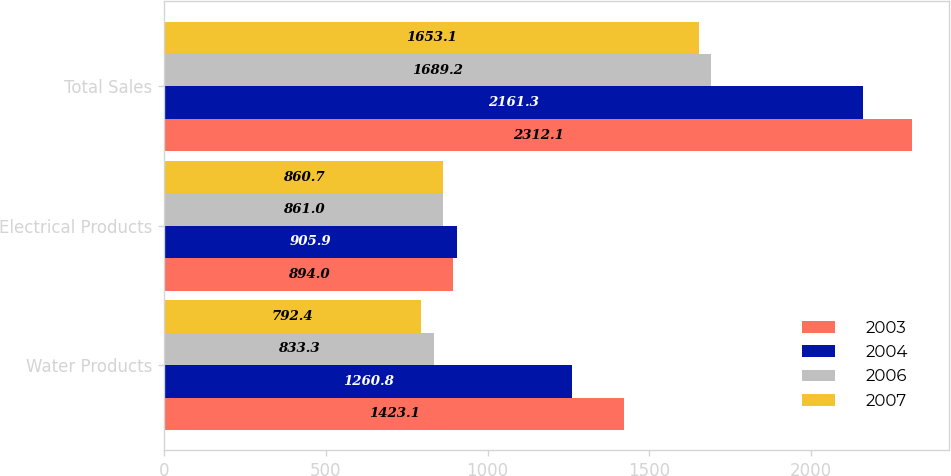Convert chart to OTSL. <chart><loc_0><loc_0><loc_500><loc_500><stacked_bar_chart><ecel><fcel>Water Products<fcel>Electrical Products<fcel>Total Sales<nl><fcel>2003<fcel>1423.1<fcel>894<fcel>2312.1<nl><fcel>2004<fcel>1260.8<fcel>905.9<fcel>2161.3<nl><fcel>2006<fcel>833.3<fcel>861<fcel>1689.2<nl><fcel>2007<fcel>792.4<fcel>860.7<fcel>1653.1<nl></chart> 